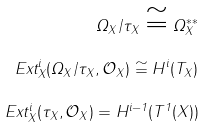<formula> <loc_0><loc_0><loc_500><loc_500>\Omega _ { X } / \tau _ { X } \cong \Omega _ { X } ^ { \ast \ast } \\ E x t _ { X } ^ { i } ( \Omega _ { X } / \tau _ { X } , \mathcal { O } _ { X } ) \cong H ^ { i } ( T _ { X } ) \\ E x t _ { X } ^ { i } ( \tau _ { X } , \mathcal { O } _ { X } ) = H ^ { i - 1 } ( T ^ { 1 } ( X ) )</formula> 